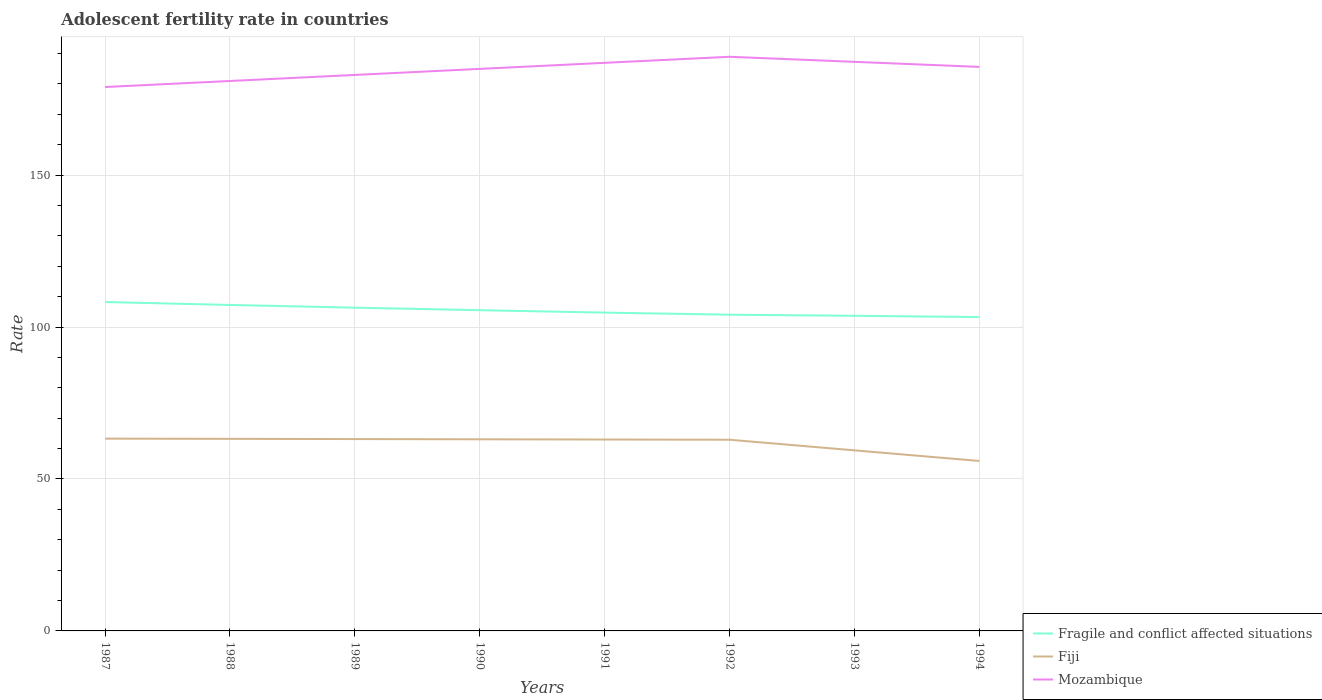Is the number of lines equal to the number of legend labels?
Provide a succinct answer. Yes. Across all years, what is the maximum adolescent fertility rate in Fiji?
Your answer should be very brief. 55.93. What is the total adolescent fertility rate in Fiji in the graph?
Ensure brevity in your answer.  0.29. What is the difference between the highest and the second highest adolescent fertility rate in Fiji?
Make the answer very short. 7.35. What is the difference between the highest and the lowest adolescent fertility rate in Mozambique?
Your response must be concise. 5. How many lines are there?
Your response must be concise. 3. How many years are there in the graph?
Your answer should be compact. 8. What is the difference between two consecutive major ticks on the Y-axis?
Make the answer very short. 50. Does the graph contain grids?
Your answer should be compact. Yes. How are the legend labels stacked?
Ensure brevity in your answer.  Vertical. What is the title of the graph?
Your answer should be compact. Adolescent fertility rate in countries. What is the label or title of the Y-axis?
Provide a short and direct response. Rate. What is the Rate in Fragile and conflict affected situations in 1987?
Give a very brief answer. 108.22. What is the Rate in Fiji in 1987?
Provide a short and direct response. 63.28. What is the Rate of Mozambique in 1987?
Make the answer very short. 178.98. What is the Rate of Fragile and conflict affected situations in 1988?
Offer a very short reply. 107.27. What is the Rate in Fiji in 1988?
Your answer should be compact. 63.21. What is the Rate in Mozambique in 1988?
Ensure brevity in your answer.  180.97. What is the Rate of Fragile and conflict affected situations in 1989?
Your response must be concise. 106.37. What is the Rate of Fiji in 1989?
Ensure brevity in your answer.  63.13. What is the Rate in Mozambique in 1989?
Ensure brevity in your answer.  182.96. What is the Rate in Fragile and conflict affected situations in 1990?
Provide a short and direct response. 105.54. What is the Rate of Fiji in 1990?
Offer a terse response. 63.06. What is the Rate in Mozambique in 1990?
Keep it short and to the point. 184.95. What is the Rate in Fragile and conflict affected situations in 1991?
Your response must be concise. 104.75. What is the Rate in Fiji in 1991?
Your answer should be compact. 62.99. What is the Rate in Mozambique in 1991?
Provide a short and direct response. 186.94. What is the Rate in Fragile and conflict affected situations in 1992?
Provide a short and direct response. 104.06. What is the Rate of Fiji in 1992?
Your response must be concise. 62.91. What is the Rate of Mozambique in 1992?
Your answer should be very brief. 188.93. What is the Rate in Fragile and conflict affected situations in 1993?
Your answer should be compact. 103.7. What is the Rate in Fiji in 1993?
Offer a terse response. 59.42. What is the Rate of Mozambique in 1993?
Keep it short and to the point. 187.27. What is the Rate in Fragile and conflict affected situations in 1994?
Your answer should be compact. 103.28. What is the Rate of Fiji in 1994?
Offer a terse response. 55.93. What is the Rate in Mozambique in 1994?
Give a very brief answer. 185.61. Across all years, what is the maximum Rate in Fragile and conflict affected situations?
Offer a terse response. 108.22. Across all years, what is the maximum Rate of Fiji?
Provide a short and direct response. 63.28. Across all years, what is the maximum Rate in Mozambique?
Your answer should be very brief. 188.93. Across all years, what is the minimum Rate in Fragile and conflict affected situations?
Offer a terse response. 103.28. Across all years, what is the minimum Rate of Fiji?
Keep it short and to the point. 55.93. Across all years, what is the minimum Rate of Mozambique?
Your response must be concise. 178.98. What is the total Rate in Fragile and conflict affected situations in the graph?
Your answer should be very brief. 843.19. What is the total Rate in Fiji in the graph?
Your response must be concise. 493.92. What is the total Rate in Mozambique in the graph?
Give a very brief answer. 1476.61. What is the difference between the Rate of Fragile and conflict affected situations in 1987 and that in 1988?
Make the answer very short. 0.95. What is the difference between the Rate in Fiji in 1987 and that in 1988?
Provide a short and direct response. 0.07. What is the difference between the Rate of Mozambique in 1987 and that in 1988?
Give a very brief answer. -1.99. What is the difference between the Rate in Fragile and conflict affected situations in 1987 and that in 1989?
Offer a terse response. 1.85. What is the difference between the Rate in Fiji in 1987 and that in 1989?
Your answer should be compact. 0.15. What is the difference between the Rate of Mozambique in 1987 and that in 1989?
Make the answer very short. -3.98. What is the difference between the Rate of Fragile and conflict affected situations in 1987 and that in 1990?
Your response must be concise. 2.68. What is the difference between the Rate in Fiji in 1987 and that in 1990?
Provide a short and direct response. 0.22. What is the difference between the Rate in Mozambique in 1987 and that in 1990?
Your answer should be very brief. -5.97. What is the difference between the Rate in Fragile and conflict affected situations in 1987 and that in 1991?
Provide a succinct answer. 3.47. What is the difference between the Rate of Fiji in 1987 and that in 1991?
Offer a terse response. 0.29. What is the difference between the Rate in Mozambique in 1987 and that in 1991?
Ensure brevity in your answer.  -7.96. What is the difference between the Rate in Fragile and conflict affected situations in 1987 and that in 1992?
Your answer should be very brief. 4.16. What is the difference between the Rate of Fiji in 1987 and that in 1992?
Provide a short and direct response. 0.37. What is the difference between the Rate of Mozambique in 1987 and that in 1992?
Make the answer very short. -9.95. What is the difference between the Rate in Fragile and conflict affected situations in 1987 and that in 1993?
Make the answer very short. 4.52. What is the difference between the Rate in Fiji in 1987 and that in 1993?
Your answer should be compact. 3.86. What is the difference between the Rate in Mozambique in 1987 and that in 1993?
Offer a terse response. -8.29. What is the difference between the Rate in Fragile and conflict affected situations in 1987 and that in 1994?
Your answer should be very brief. 4.94. What is the difference between the Rate of Fiji in 1987 and that in 1994?
Your answer should be compact. 7.35. What is the difference between the Rate of Mozambique in 1987 and that in 1994?
Provide a succinct answer. -6.63. What is the difference between the Rate in Fragile and conflict affected situations in 1988 and that in 1989?
Provide a succinct answer. 0.9. What is the difference between the Rate of Fiji in 1988 and that in 1989?
Keep it short and to the point. 0.07. What is the difference between the Rate of Mozambique in 1988 and that in 1989?
Your answer should be compact. -1.99. What is the difference between the Rate in Fragile and conflict affected situations in 1988 and that in 1990?
Offer a terse response. 1.73. What is the difference between the Rate of Fiji in 1988 and that in 1990?
Your answer should be compact. 0.15. What is the difference between the Rate of Mozambique in 1988 and that in 1990?
Give a very brief answer. -3.98. What is the difference between the Rate of Fragile and conflict affected situations in 1988 and that in 1991?
Give a very brief answer. 2.52. What is the difference between the Rate of Fiji in 1988 and that in 1991?
Offer a terse response. 0.22. What is the difference between the Rate of Mozambique in 1988 and that in 1991?
Ensure brevity in your answer.  -5.97. What is the difference between the Rate in Fragile and conflict affected situations in 1988 and that in 1992?
Provide a succinct answer. 3.21. What is the difference between the Rate in Fiji in 1988 and that in 1992?
Give a very brief answer. 0.29. What is the difference between the Rate in Mozambique in 1988 and that in 1992?
Give a very brief answer. -7.96. What is the difference between the Rate in Fragile and conflict affected situations in 1988 and that in 1993?
Make the answer very short. 3.56. What is the difference between the Rate in Fiji in 1988 and that in 1993?
Your response must be concise. 3.79. What is the difference between the Rate in Mozambique in 1988 and that in 1993?
Provide a succinct answer. -6.3. What is the difference between the Rate of Fragile and conflict affected situations in 1988 and that in 1994?
Ensure brevity in your answer.  3.99. What is the difference between the Rate in Fiji in 1988 and that in 1994?
Keep it short and to the point. 7.28. What is the difference between the Rate of Mozambique in 1988 and that in 1994?
Provide a short and direct response. -4.64. What is the difference between the Rate in Fragile and conflict affected situations in 1989 and that in 1990?
Ensure brevity in your answer.  0.83. What is the difference between the Rate of Fiji in 1989 and that in 1990?
Ensure brevity in your answer.  0.07. What is the difference between the Rate of Mozambique in 1989 and that in 1990?
Give a very brief answer. -1.99. What is the difference between the Rate of Fragile and conflict affected situations in 1989 and that in 1991?
Make the answer very short. 1.62. What is the difference between the Rate in Fiji in 1989 and that in 1991?
Ensure brevity in your answer.  0.15. What is the difference between the Rate of Mozambique in 1989 and that in 1991?
Make the answer very short. -3.98. What is the difference between the Rate in Fragile and conflict affected situations in 1989 and that in 1992?
Provide a short and direct response. 2.31. What is the difference between the Rate in Fiji in 1989 and that in 1992?
Give a very brief answer. 0.22. What is the difference between the Rate of Mozambique in 1989 and that in 1992?
Your answer should be very brief. -5.97. What is the difference between the Rate of Fragile and conflict affected situations in 1989 and that in 1993?
Offer a terse response. 2.67. What is the difference between the Rate in Fiji in 1989 and that in 1993?
Ensure brevity in your answer.  3.71. What is the difference between the Rate in Mozambique in 1989 and that in 1993?
Provide a short and direct response. -4.31. What is the difference between the Rate of Fragile and conflict affected situations in 1989 and that in 1994?
Provide a succinct answer. 3.09. What is the difference between the Rate in Fiji in 1989 and that in 1994?
Offer a terse response. 7.2. What is the difference between the Rate in Mozambique in 1989 and that in 1994?
Give a very brief answer. -2.65. What is the difference between the Rate of Fragile and conflict affected situations in 1990 and that in 1991?
Offer a terse response. 0.79. What is the difference between the Rate of Fiji in 1990 and that in 1991?
Your answer should be very brief. 0.07. What is the difference between the Rate in Mozambique in 1990 and that in 1991?
Give a very brief answer. -1.99. What is the difference between the Rate in Fragile and conflict affected situations in 1990 and that in 1992?
Give a very brief answer. 1.48. What is the difference between the Rate in Fiji in 1990 and that in 1992?
Offer a very short reply. 0.15. What is the difference between the Rate in Mozambique in 1990 and that in 1992?
Ensure brevity in your answer.  -3.98. What is the difference between the Rate of Fragile and conflict affected situations in 1990 and that in 1993?
Make the answer very short. 1.84. What is the difference between the Rate of Fiji in 1990 and that in 1993?
Make the answer very short. 3.64. What is the difference between the Rate in Mozambique in 1990 and that in 1993?
Give a very brief answer. -2.32. What is the difference between the Rate of Fragile and conflict affected situations in 1990 and that in 1994?
Your answer should be very brief. 2.26. What is the difference between the Rate of Fiji in 1990 and that in 1994?
Keep it short and to the point. 7.13. What is the difference between the Rate of Mozambique in 1990 and that in 1994?
Make the answer very short. -0.65. What is the difference between the Rate in Fragile and conflict affected situations in 1991 and that in 1992?
Your answer should be very brief. 0.69. What is the difference between the Rate in Fiji in 1991 and that in 1992?
Offer a terse response. 0.07. What is the difference between the Rate of Mozambique in 1991 and that in 1992?
Offer a terse response. -1.99. What is the difference between the Rate of Fragile and conflict affected situations in 1991 and that in 1993?
Make the answer very short. 1.05. What is the difference between the Rate in Fiji in 1991 and that in 1993?
Your response must be concise. 3.57. What is the difference between the Rate of Mozambique in 1991 and that in 1993?
Keep it short and to the point. -0.33. What is the difference between the Rate of Fragile and conflict affected situations in 1991 and that in 1994?
Offer a very short reply. 1.47. What is the difference between the Rate in Fiji in 1991 and that in 1994?
Your answer should be very brief. 7.06. What is the difference between the Rate of Mozambique in 1991 and that in 1994?
Provide a succinct answer. 1.34. What is the difference between the Rate in Fragile and conflict affected situations in 1992 and that in 1993?
Provide a succinct answer. 0.36. What is the difference between the Rate of Fiji in 1992 and that in 1993?
Your answer should be very brief. 3.49. What is the difference between the Rate of Mozambique in 1992 and that in 1993?
Keep it short and to the point. 1.66. What is the difference between the Rate of Fragile and conflict affected situations in 1992 and that in 1994?
Provide a short and direct response. 0.78. What is the difference between the Rate in Fiji in 1992 and that in 1994?
Your answer should be very brief. 6.98. What is the difference between the Rate of Mozambique in 1992 and that in 1994?
Your answer should be compact. 3.33. What is the difference between the Rate of Fragile and conflict affected situations in 1993 and that in 1994?
Offer a terse response. 0.42. What is the difference between the Rate in Fiji in 1993 and that in 1994?
Provide a short and direct response. 3.49. What is the difference between the Rate in Mozambique in 1993 and that in 1994?
Make the answer very short. 1.66. What is the difference between the Rate of Fragile and conflict affected situations in 1987 and the Rate of Fiji in 1988?
Offer a terse response. 45.02. What is the difference between the Rate in Fragile and conflict affected situations in 1987 and the Rate in Mozambique in 1988?
Your answer should be compact. -72.75. What is the difference between the Rate in Fiji in 1987 and the Rate in Mozambique in 1988?
Keep it short and to the point. -117.69. What is the difference between the Rate in Fragile and conflict affected situations in 1987 and the Rate in Fiji in 1989?
Keep it short and to the point. 45.09. What is the difference between the Rate of Fragile and conflict affected situations in 1987 and the Rate of Mozambique in 1989?
Your response must be concise. -74.74. What is the difference between the Rate in Fiji in 1987 and the Rate in Mozambique in 1989?
Provide a succinct answer. -119.68. What is the difference between the Rate of Fragile and conflict affected situations in 1987 and the Rate of Fiji in 1990?
Make the answer very short. 45.16. What is the difference between the Rate in Fragile and conflict affected situations in 1987 and the Rate in Mozambique in 1990?
Provide a short and direct response. -76.73. What is the difference between the Rate of Fiji in 1987 and the Rate of Mozambique in 1990?
Offer a terse response. -121.67. What is the difference between the Rate of Fragile and conflict affected situations in 1987 and the Rate of Fiji in 1991?
Offer a terse response. 45.23. What is the difference between the Rate of Fragile and conflict affected situations in 1987 and the Rate of Mozambique in 1991?
Your answer should be very brief. -78.72. What is the difference between the Rate of Fiji in 1987 and the Rate of Mozambique in 1991?
Your response must be concise. -123.66. What is the difference between the Rate in Fragile and conflict affected situations in 1987 and the Rate in Fiji in 1992?
Your answer should be very brief. 45.31. What is the difference between the Rate of Fragile and conflict affected situations in 1987 and the Rate of Mozambique in 1992?
Give a very brief answer. -80.71. What is the difference between the Rate of Fiji in 1987 and the Rate of Mozambique in 1992?
Provide a short and direct response. -125.65. What is the difference between the Rate of Fragile and conflict affected situations in 1987 and the Rate of Fiji in 1993?
Make the answer very short. 48.8. What is the difference between the Rate in Fragile and conflict affected situations in 1987 and the Rate in Mozambique in 1993?
Keep it short and to the point. -79.05. What is the difference between the Rate of Fiji in 1987 and the Rate of Mozambique in 1993?
Ensure brevity in your answer.  -123.99. What is the difference between the Rate in Fragile and conflict affected situations in 1987 and the Rate in Fiji in 1994?
Keep it short and to the point. 52.29. What is the difference between the Rate of Fragile and conflict affected situations in 1987 and the Rate of Mozambique in 1994?
Keep it short and to the point. -77.38. What is the difference between the Rate in Fiji in 1987 and the Rate in Mozambique in 1994?
Make the answer very short. -122.33. What is the difference between the Rate of Fragile and conflict affected situations in 1988 and the Rate of Fiji in 1989?
Keep it short and to the point. 44.14. What is the difference between the Rate of Fragile and conflict affected situations in 1988 and the Rate of Mozambique in 1989?
Offer a terse response. -75.69. What is the difference between the Rate of Fiji in 1988 and the Rate of Mozambique in 1989?
Provide a succinct answer. -119.75. What is the difference between the Rate of Fragile and conflict affected situations in 1988 and the Rate of Fiji in 1990?
Provide a short and direct response. 44.21. What is the difference between the Rate of Fragile and conflict affected situations in 1988 and the Rate of Mozambique in 1990?
Provide a succinct answer. -77.68. What is the difference between the Rate in Fiji in 1988 and the Rate in Mozambique in 1990?
Your answer should be very brief. -121.75. What is the difference between the Rate in Fragile and conflict affected situations in 1988 and the Rate in Fiji in 1991?
Make the answer very short. 44.28. What is the difference between the Rate of Fragile and conflict affected situations in 1988 and the Rate of Mozambique in 1991?
Your response must be concise. -79.67. What is the difference between the Rate in Fiji in 1988 and the Rate in Mozambique in 1991?
Offer a terse response. -123.74. What is the difference between the Rate in Fragile and conflict affected situations in 1988 and the Rate in Fiji in 1992?
Your response must be concise. 44.35. What is the difference between the Rate of Fragile and conflict affected situations in 1988 and the Rate of Mozambique in 1992?
Your answer should be compact. -81.66. What is the difference between the Rate in Fiji in 1988 and the Rate in Mozambique in 1992?
Make the answer very short. -125.73. What is the difference between the Rate in Fragile and conflict affected situations in 1988 and the Rate in Fiji in 1993?
Your answer should be compact. 47.85. What is the difference between the Rate in Fragile and conflict affected situations in 1988 and the Rate in Mozambique in 1993?
Provide a succinct answer. -80. What is the difference between the Rate in Fiji in 1988 and the Rate in Mozambique in 1993?
Give a very brief answer. -124.06. What is the difference between the Rate in Fragile and conflict affected situations in 1988 and the Rate in Fiji in 1994?
Provide a succinct answer. 51.34. What is the difference between the Rate of Fragile and conflict affected situations in 1988 and the Rate of Mozambique in 1994?
Make the answer very short. -78.34. What is the difference between the Rate of Fiji in 1988 and the Rate of Mozambique in 1994?
Make the answer very short. -122.4. What is the difference between the Rate of Fragile and conflict affected situations in 1989 and the Rate of Fiji in 1990?
Keep it short and to the point. 43.31. What is the difference between the Rate in Fragile and conflict affected situations in 1989 and the Rate in Mozambique in 1990?
Provide a short and direct response. -78.58. What is the difference between the Rate in Fiji in 1989 and the Rate in Mozambique in 1990?
Keep it short and to the point. -121.82. What is the difference between the Rate of Fragile and conflict affected situations in 1989 and the Rate of Fiji in 1991?
Your answer should be compact. 43.39. What is the difference between the Rate of Fragile and conflict affected situations in 1989 and the Rate of Mozambique in 1991?
Your answer should be compact. -80.57. What is the difference between the Rate in Fiji in 1989 and the Rate in Mozambique in 1991?
Offer a very short reply. -123.81. What is the difference between the Rate of Fragile and conflict affected situations in 1989 and the Rate of Fiji in 1992?
Keep it short and to the point. 43.46. What is the difference between the Rate of Fragile and conflict affected situations in 1989 and the Rate of Mozambique in 1992?
Your answer should be compact. -82.56. What is the difference between the Rate of Fiji in 1989 and the Rate of Mozambique in 1992?
Offer a terse response. -125.8. What is the difference between the Rate of Fragile and conflict affected situations in 1989 and the Rate of Fiji in 1993?
Provide a short and direct response. 46.95. What is the difference between the Rate in Fragile and conflict affected situations in 1989 and the Rate in Mozambique in 1993?
Offer a very short reply. -80.9. What is the difference between the Rate of Fiji in 1989 and the Rate of Mozambique in 1993?
Your answer should be compact. -124.14. What is the difference between the Rate of Fragile and conflict affected situations in 1989 and the Rate of Fiji in 1994?
Your answer should be compact. 50.44. What is the difference between the Rate of Fragile and conflict affected situations in 1989 and the Rate of Mozambique in 1994?
Make the answer very short. -79.23. What is the difference between the Rate in Fiji in 1989 and the Rate in Mozambique in 1994?
Offer a terse response. -122.47. What is the difference between the Rate of Fragile and conflict affected situations in 1990 and the Rate of Fiji in 1991?
Provide a short and direct response. 42.55. What is the difference between the Rate of Fragile and conflict affected situations in 1990 and the Rate of Mozambique in 1991?
Offer a terse response. -81.4. What is the difference between the Rate in Fiji in 1990 and the Rate in Mozambique in 1991?
Ensure brevity in your answer.  -123.88. What is the difference between the Rate of Fragile and conflict affected situations in 1990 and the Rate of Fiji in 1992?
Your answer should be compact. 42.63. What is the difference between the Rate of Fragile and conflict affected situations in 1990 and the Rate of Mozambique in 1992?
Make the answer very short. -83.39. What is the difference between the Rate of Fiji in 1990 and the Rate of Mozambique in 1992?
Offer a very short reply. -125.87. What is the difference between the Rate of Fragile and conflict affected situations in 1990 and the Rate of Fiji in 1993?
Make the answer very short. 46.12. What is the difference between the Rate of Fragile and conflict affected situations in 1990 and the Rate of Mozambique in 1993?
Offer a terse response. -81.73. What is the difference between the Rate in Fiji in 1990 and the Rate in Mozambique in 1993?
Ensure brevity in your answer.  -124.21. What is the difference between the Rate in Fragile and conflict affected situations in 1990 and the Rate in Fiji in 1994?
Provide a succinct answer. 49.61. What is the difference between the Rate of Fragile and conflict affected situations in 1990 and the Rate of Mozambique in 1994?
Your answer should be very brief. -80.07. What is the difference between the Rate in Fiji in 1990 and the Rate in Mozambique in 1994?
Keep it short and to the point. -122.55. What is the difference between the Rate of Fragile and conflict affected situations in 1991 and the Rate of Fiji in 1992?
Your answer should be very brief. 41.84. What is the difference between the Rate in Fragile and conflict affected situations in 1991 and the Rate in Mozambique in 1992?
Make the answer very short. -84.18. What is the difference between the Rate in Fiji in 1991 and the Rate in Mozambique in 1992?
Provide a short and direct response. -125.95. What is the difference between the Rate of Fragile and conflict affected situations in 1991 and the Rate of Fiji in 1993?
Your response must be concise. 45.33. What is the difference between the Rate in Fragile and conflict affected situations in 1991 and the Rate in Mozambique in 1993?
Ensure brevity in your answer.  -82.52. What is the difference between the Rate of Fiji in 1991 and the Rate of Mozambique in 1993?
Your answer should be very brief. -124.28. What is the difference between the Rate of Fragile and conflict affected situations in 1991 and the Rate of Fiji in 1994?
Provide a short and direct response. 48.82. What is the difference between the Rate in Fragile and conflict affected situations in 1991 and the Rate in Mozambique in 1994?
Keep it short and to the point. -80.86. What is the difference between the Rate of Fiji in 1991 and the Rate of Mozambique in 1994?
Offer a very short reply. -122.62. What is the difference between the Rate of Fragile and conflict affected situations in 1992 and the Rate of Fiji in 1993?
Your response must be concise. 44.64. What is the difference between the Rate in Fragile and conflict affected situations in 1992 and the Rate in Mozambique in 1993?
Keep it short and to the point. -83.21. What is the difference between the Rate of Fiji in 1992 and the Rate of Mozambique in 1993?
Give a very brief answer. -124.36. What is the difference between the Rate of Fragile and conflict affected situations in 1992 and the Rate of Fiji in 1994?
Your answer should be compact. 48.13. What is the difference between the Rate of Fragile and conflict affected situations in 1992 and the Rate of Mozambique in 1994?
Your answer should be very brief. -81.54. What is the difference between the Rate of Fiji in 1992 and the Rate of Mozambique in 1994?
Make the answer very short. -122.69. What is the difference between the Rate in Fragile and conflict affected situations in 1993 and the Rate in Fiji in 1994?
Offer a terse response. 47.77. What is the difference between the Rate in Fragile and conflict affected situations in 1993 and the Rate in Mozambique in 1994?
Keep it short and to the point. -81.9. What is the difference between the Rate in Fiji in 1993 and the Rate in Mozambique in 1994?
Make the answer very short. -126.18. What is the average Rate of Fragile and conflict affected situations per year?
Make the answer very short. 105.4. What is the average Rate of Fiji per year?
Offer a very short reply. 61.74. What is the average Rate of Mozambique per year?
Provide a short and direct response. 184.58. In the year 1987, what is the difference between the Rate in Fragile and conflict affected situations and Rate in Fiji?
Provide a short and direct response. 44.94. In the year 1987, what is the difference between the Rate of Fragile and conflict affected situations and Rate of Mozambique?
Offer a terse response. -70.76. In the year 1987, what is the difference between the Rate in Fiji and Rate in Mozambique?
Ensure brevity in your answer.  -115.7. In the year 1988, what is the difference between the Rate in Fragile and conflict affected situations and Rate in Fiji?
Keep it short and to the point. 44.06. In the year 1988, what is the difference between the Rate in Fragile and conflict affected situations and Rate in Mozambique?
Your answer should be very brief. -73.7. In the year 1988, what is the difference between the Rate of Fiji and Rate of Mozambique?
Your answer should be very brief. -117.76. In the year 1989, what is the difference between the Rate in Fragile and conflict affected situations and Rate in Fiji?
Provide a succinct answer. 43.24. In the year 1989, what is the difference between the Rate of Fragile and conflict affected situations and Rate of Mozambique?
Provide a short and direct response. -76.59. In the year 1989, what is the difference between the Rate of Fiji and Rate of Mozambique?
Your answer should be compact. -119.83. In the year 1990, what is the difference between the Rate in Fragile and conflict affected situations and Rate in Fiji?
Keep it short and to the point. 42.48. In the year 1990, what is the difference between the Rate of Fragile and conflict affected situations and Rate of Mozambique?
Provide a succinct answer. -79.41. In the year 1990, what is the difference between the Rate of Fiji and Rate of Mozambique?
Provide a short and direct response. -121.89. In the year 1991, what is the difference between the Rate of Fragile and conflict affected situations and Rate of Fiji?
Your answer should be very brief. 41.76. In the year 1991, what is the difference between the Rate of Fragile and conflict affected situations and Rate of Mozambique?
Give a very brief answer. -82.19. In the year 1991, what is the difference between the Rate in Fiji and Rate in Mozambique?
Your answer should be very brief. -123.96. In the year 1992, what is the difference between the Rate of Fragile and conflict affected situations and Rate of Fiji?
Your answer should be very brief. 41.15. In the year 1992, what is the difference between the Rate of Fragile and conflict affected situations and Rate of Mozambique?
Provide a short and direct response. -84.87. In the year 1992, what is the difference between the Rate of Fiji and Rate of Mozambique?
Provide a succinct answer. -126.02. In the year 1993, what is the difference between the Rate of Fragile and conflict affected situations and Rate of Fiji?
Offer a very short reply. 44.28. In the year 1993, what is the difference between the Rate of Fragile and conflict affected situations and Rate of Mozambique?
Provide a succinct answer. -83.57. In the year 1993, what is the difference between the Rate in Fiji and Rate in Mozambique?
Provide a succinct answer. -127.85. In the year 1994, what is the difference between the Rate of Fragile and conflict affected situations and Rate of Fiji?
Offer a terse response. 47.35. In the year 1994, what is the difference between the Rate of Fragile and conflict affected situations and Rate of Mozambique?
Give a very brief answer. -82.33. In the year 1994, what is the difference between the Rate in Fiji and Rate in Mozambique?
Provide a short and direct response. -129.68. What is the ratio of the Rate of Fragile and conflict affected situations in 1987 to that in 1988?
Provide a succinct answer. 1.01. What is the ratio of the Rate of Fiji in 1987 to that in 1988?
Your answer should be very brief. 1. What is the ratio of the Rate in Fragile and conflict affected situations in 1987 to that in 1989?
Ensure brevity in your answer.  1.02. What is the ratio of the Rate in Fiji in 1987 to that in 1989?
Your response must be concise. 1. What is the ratio of the Rate in Mozambique in 1987 to that in 1989?
Offer a very short reply. 0.98. What is the ratio of the Rate in Fragile and conflict affected situations in 1987 to that in 1990?
Provide a succinct answer. 1.03. What is the ratio of the Rate of Fragile and conflict affected situations in 1987 to that in 1991?
Offer a terse response. 1.03. What is the ratio of the Rate in Mozambique in 1987 to that in 1991?
Offer a terse response. 0.96. What is the ratio of the Rate in Fiji in 1987 to that in 1992?
Your response must be concise. 1.01. What is the ratio of the Rate in Mozambique in 1987 to that in 1992?
Offer a very short reply. 0.95. What is the ratio of the Rate in Fragile and conflict affected situations in 1987 to that in 1993?
Offer a terse response. 1.04. What is the ratio of the Rate in Fiji in 1987 to that in 1993?
Your answer should be compact. 1.06. What is the ratio of the Rate of Mozambique in 1987 to that in 1993?
Your response must be concise. 0.96. What is the ratio of the Rate of Fragile and conflict affected situations in 1987 to that in 1994?
Your answer should be very brief. 1.05. What is the ratio of the Rate of Fiji in 1987 to that in 1994?
Offer a very short reply. 1.13. What is the ratio of the Rate in Mozambique in 1987 to that in 1994?
Ensure brevity in your answer.  0.96. What is the ratio of the Rate in Fragile and conflict affected situations in 1988 to that in 1989?
Keep it short and to the point. 1.01. What is the ratio of the Rate in Fiji in 1988 to that in 1989?
Your response must be concise. 1. What is the ratio of the Rate of Mozambique in 1988 to that in 1989?
Provide a short and direct response. 0.99. What is the ratio of the Rate of Fragile and conflict affected situations in 1988 to that in 1990?
Give a very brief answer. 1.02. What is the ratio of the Rate in Fiji in 1988 to that in 1990?
Give a very brief answer. 1. What is the ratio of the Rate in Mozambique in 1988 to that in 1990?
Your response must be concise. 0.98. What is the ratio of the Rate in Fiji in 1988 to that in 1991?
Ensure brevity in your answer.  1. What is the ratio of the Rate in Mozambique in 1988 to that in 1991?
Offer a terse response. 0.97. What is the ratio of the Rate in Fragile and conflict affected situations in 1988 to that in 1992?
Your answer should be compact. 1.03. What is the ratio of the Rate of Mozambique in 1988 to that in 1992?
Your answer should be compact. 0.96. What is the ratio of the Rate of Fragile and conflict affected situations in 1988 to that in 1993?
Your answer should be compact. 1.03. What is the ratio of the Rate of Fiji in 1988 to that in 1993?
Provide a short and direct response. 1.06. What is the ratio of the Rate of Mozambique in 1988 to that in 1993?
Offer a terse response. 0.97. What is the ratio of the Rate of Fragile and conflict affected situations in 1988 to that in 1994?
Provide a succinct answer. 1.04. What is the ratio of the Rate of Fiji in 1988 to that in 1994?
Offer a terse response. 1.13. What is the ratio of the Rate in Fragile and conflict affected situations in 1989 to that in 1990?
Your response must be concise. 1.01. What is the ratio of the Rate of Fiji in 1989 to that in 1990?
Provide a succinct answer. 1. What is the ratio of the Rate in Fragile and conflict affected situations in 1989 to that in 1991?
Provide a short and direct response. 1.02. What is the ratio of the Rate of Mozambique in 1989 to that in 1991?
Make the answer very short. 0.98. What is the ratio of the Rate in Fragile and conflict affected situations in 1989 to that in 1992?
Your answer should be very brief. 1.02. What is the ratio of the Rate of Fiji in 1989 to that in 1992?
Keep it short and to the point. 1. What is the ratio of the Rate in Mozambique in 1989 to that in 1992?
Your response must be concise. 0.97. What is the ratio of the Rate of Fragile and conflict affected situations in 1989 to that in 1993?
Your answer should be very brief. 1.03. What is the ratio of the Rate in Mozambique in 1989 to that in 1993?
Your response must be concise. 0.98. What is the ratio of the Rate of Fragile and conflict affected situations in 1989 to that in 1994?
Offer a very short reply. 1.03. What is the ratio of the Rate in Fiji in 1989 to that in 1994?
Offer a terse response. 1.13. What is the ratio of the Rate of Mozambique in 1989 to that in 1994?
Provide a succinct answer. 0.99. What is the ratio of the Rate in Fragile and conflict affected situations in 1990 to that in 1991?
Make the answer very short. 1.01. What is the ratio of the Rate in Fragile and conflict affected situations in 1990 to that in 1992?
Ensure brevity in your answer.  1.01. What is the ratio of the Rate in Mozambique in 1990 to that in 1992?
Provide a succinct answer. 0.98. What is the ratio of the Rate of Fragile and conflict affected situations in 1990 to that in 1993?
Offer a terse response. 1.02. What is the ratio of the Rate in Fiji in 1990 to that in 1993?
Give a very brief answer. 1.06. What is the ratio of the Rate of Mozambique in 1990 to that in 1993?
Provide a succinct answer. 0.99. What is the ratio of the Rate in Fragile and conflict affected situations in 1990 to that in 1994?
Offer a very short reply. 1.02. What is the ratio of the Rate in Fiji in 1990 to that in 1994?
Offer a very short reply. 1.13. What is the ratio of the Rate of Fragile and conflict affected situations in 1991 to that in 1992?
Provide a short and direct response. 1.01. What is the ratio of the Rate of Fiji in 1991 to that in 1993?
Offer a terse response. 1.06. What is the ratio of the Rate in Fragile and conflict affected situations in 1991 to that in 1994?
Your answer should be compact. 1.01. What is the ratio of the Rate in Fiji in 1991 to that in 1994?
Ensure brevity in your answer.  1.13. What is the ratio of the Rate in Fiji in 1992 to that in 1993?
Provide a short and direct response. 1.06. What is the ratio of the Rate of Mozambique in 1992 to that in 1993?
Your answer should be very brief. 1.01. What is the ratio of the Rate in Fragile and conflict affected situations in 1992 to that in 1994?
Give a very brief answer. 1.01. What is the ratio of the Rate in Fiji in 1992 to that in 1994?
Ensure brevity in your answer.  1.12. What is the ratio of the Rate of Mozambique in 1992 to that in 1994?
Make the answer very short. 1.02. What is the ratio of the Rate of Fiji in 1993 to that in 1994?
Make the answer very short. 1.06. What is the ratio of the Rate of Mozambique in 1993 to that in 1994?
Keep it short and to the point. 1.01. What is the difference between the highest and the second highest Rate of Fragile and conflict affected situations?
Provide a succinct answer. 0.95. What is the difference between the highest and the second highest Rate of Fiji?
Keep it short and to the point. 0.07. What is the difference between the highest and the second highest Rate in Mozambique?
Offer a terse response. 1.66. What is the difference between the highest and the lowest Rate of Fragile and conflict affected situations?
Your answer should be compact. 4.94. What is the difference between the highest and the lowest Rate of Fiji?
Make the answer very short. 7.35. What is the difference between the highest and the lowest Rate in Mozambique?
Provide a short and direct response. 9.95. 